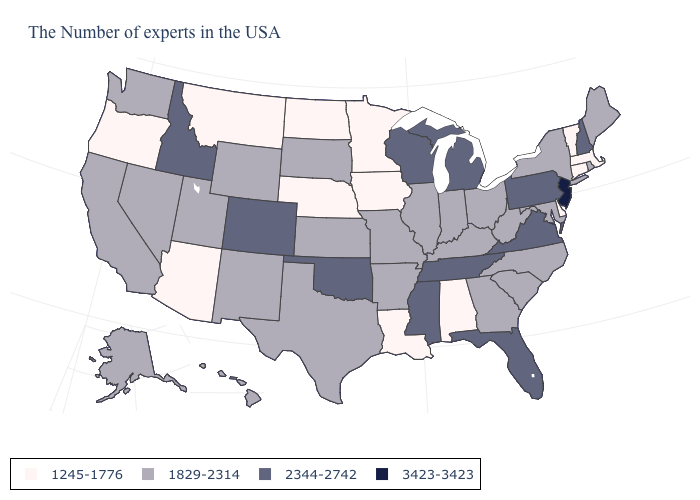Among the states that border Georgia , does Alabama have the lowest value?
Answer briefly. Yes. What is the value of Wyoming?
Answer briefly. 1829-2314. What is the value of Delaware?
Concise answer only. 1245-1776. Among the states that border Oregon , does California have the highest value?
Write a very short answer. No. What is the highest value in states that border Michigan?
Concise answer only. 2344-2742. Among the states that border Alabama , does Florida have the highest value?
Short answer required. Yes. What is the value of Vermont?
Concise answer only. 1245-1776. What is the value of North Dakota?
Keep it brief. 1245-1776. Name the states that have a value in the range 1829-2314?
Answer briefly. Maine, Rhode Island, New York, Maryland, North Carolina, South Carolina, West Virginia, Ohio, Georgia, Kentucky, Indiana, Illinois, Missouri, Arkansas, Kansas, Texas, South Dakota, Wyoming, New Mexico, Utah, Nevada, California, Washington, Alaska, Hawaii. Name the states that have a value in the range 2344-2742?
Write a very short answer. New Hampshire, Pennsylvania, Virginia, Florida, Michigan, Tennessee, Wisconsin, Mississippi, Oklahoma, Colorado, Idaho. Among the states that border Tennessee , which have the lowest value?
Write a very short answer. Alabama. Does the map have missing data?
Concise answer only. No. How many symbols are there in the legend?
Keep it brief. 4. What is the lowest value in the USA?
Concise answer only. 1245-1776. How many symbols are there in the legend?
Be succinct. 4. 